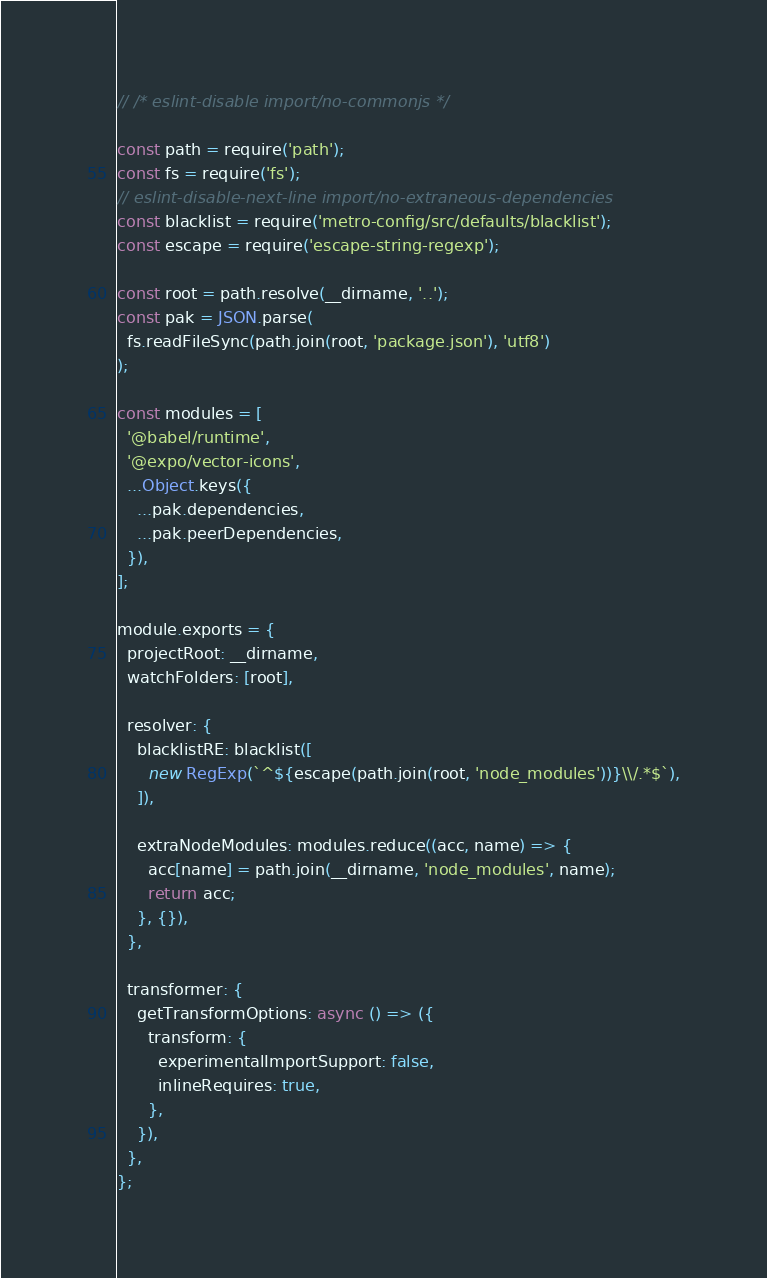Convert code to text. <code><loc_0><loc_0><loc_500><loc_500><_JavaScript_>// /* eslint-disable import/no-commonjs */

const path = require('path');
const fs = require('fs');
// eslint-disable-next-line import/no-extraneous-dependencies
const blacklist = require('metro-config/src/defaults/blacklist');
const escape = require('escape-string-regexp');

const root = path.resolve(__dirname, '..');
const pak = JSON.parse(
  fs.readFileSync(path.join(root, 'package.json'), 'utf8')
);

const modules = [
  '@babel/runtime',
  '@expo/vector-icons',
  ...Object.keys({
    ...pak.dependencies,
    ...pak.peerDependencies,
  }),
];

module.exports = {
  projectRoot: __dirname,
  watchFolders: [root],

  resolver: {
    blacklistRE: blacklist([
      new RegExp(`^${escape(path.join(root, 'node_modules'))}\\/.*$`),
    ]),

    extraNodeModules: modules.reduce((acc, name) => {
      acc[name] = path.join(__dirname, 'node_modules', name);
      return acc;
    }, {}),
  },

  transformer: {
    getTransformOptions: async () => ({
      transform: {
        experimentalImportSupport: false,
        inlineRequires: true,
      },
    }),
  },
};
</code> 